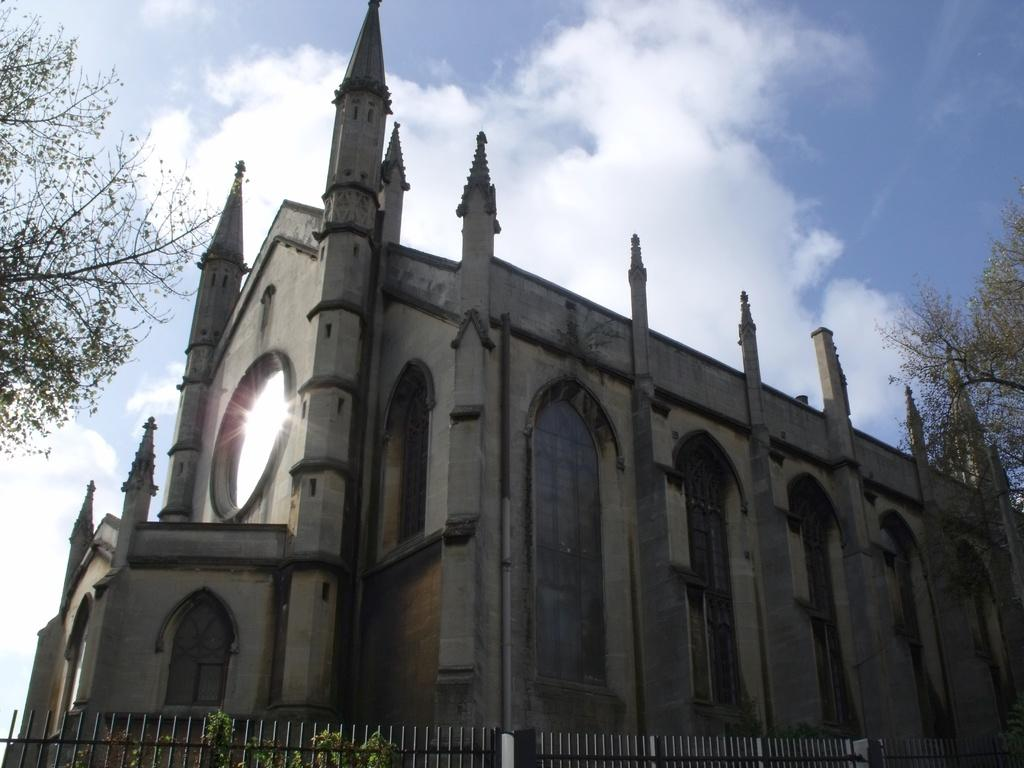What can be seen in the image that serves as a barrier or divider? There is a railing in the image. What type of natural elements are present in the image? There are plants and trees visible in the image. What structure is located behind the railing? There is a building behind the railing. What is the setting of the image? The image features a building surrounded by trees and plants, with the sky visible in the background. What type of cheese can be seen in the image? There is no cheese present in the image. How does the fog affect the visibility of the scene in the image? There is no fog present in the image; the sky is visible in the background. 